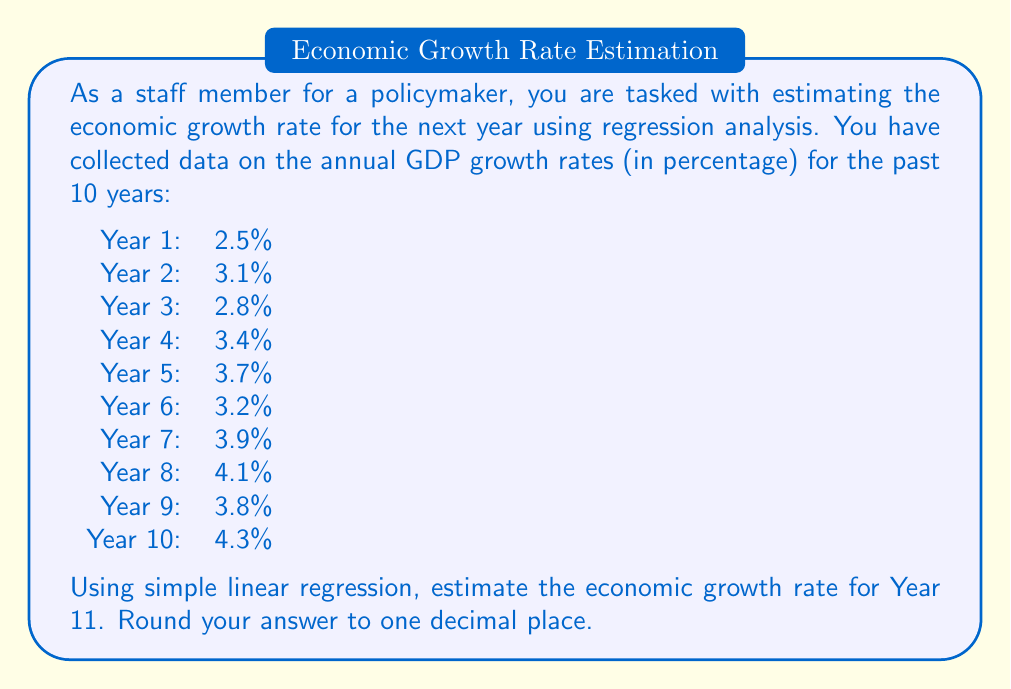Help me with this question. To estimate the economic growth rate for Year 11 using simple linear regression, we'll follow these steps:

1. Set up the linear regression equation:
   $$y = mx + b$$
   where $y$ is the GDP growth rate, $x$ is the year number, $m$ is the slope, and $b$ is the y-intercept.

2. Calculate the means of $x$ and $y$:
   $$\bar{x} = \frac{1 + 2 + 3 + 4 + 5 + 6 + 7 + 8 + 9 + 10}{10} = 5.5$$
   $$\bar{y} = \frac{2.5 + 3.1 + 2.8 + 3.4 + 3.7 + 3.2 + 3.9 + 4.1 + 3.8 + 4.3}{10} = 3.48$$

3. Calculate the slope $m$:
   $$m = \frac{\sum_{i=1}^{n} (x_i - \bar{x})(y_i - \bar{y})}{\sum_{i=1}^{n} (x_i - \bar{x})^2}$$

   Numerator: $(1-5.5)(2.5-3.48) + (2-5.5)(3.1-3.48) + ... + (10-5.5)(4.3-3.48) = 13.45$
   Denominator: $(1-5.5)^2 + (2-5.5)^2 + ... + (10-5.5)^2 = 82.5$

   $$m = \frac{13.45}{82.5} = 0.163$$

4. Calculate the y-intercept $b$:
   $$b = \bar{y} - m\bar{x} = 3.48 - 0.163 * 5.5 = 2.5835$$

5. The regression equation is:
   $$y = 0.163x + 2.5835$$

6. To estimate the growth rate for Year 11, substitute $x = 11$:
   $$y = 0.163 * 11 + 2.5835 = 4.3765$$

7. Rounding to one decimal place: 4.4%
Answer: 4.4% 